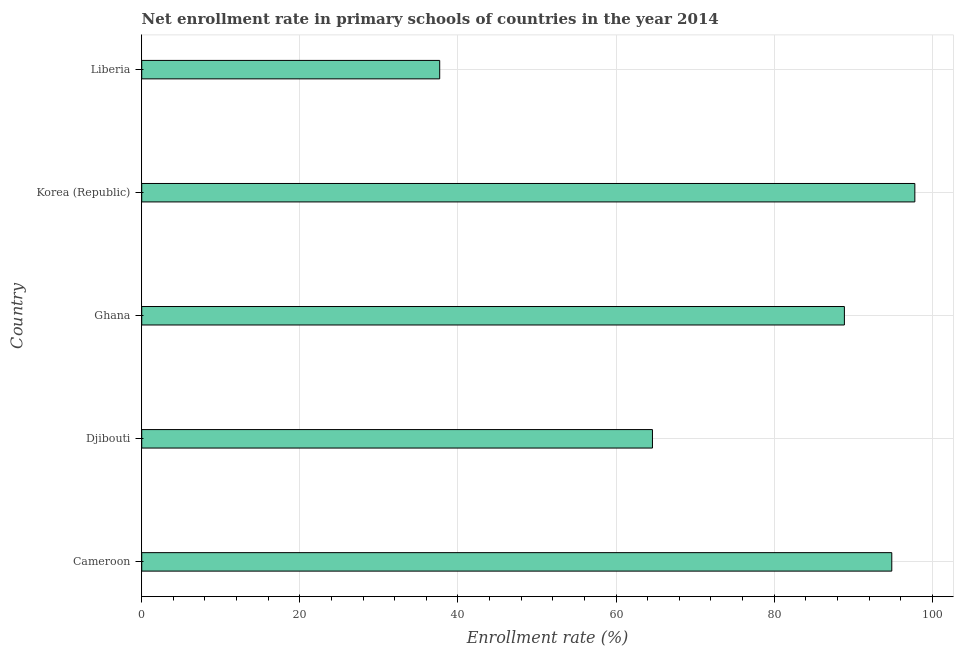What is the title of the graph?
Your answer should be compact. Net enrollment rate in primary schools of countries in the year 2014. What is the label or title of the X-axis?
Provide a succinct answer. Enrollment rate (%). What is the net enrollment rate in primary schools in Cameroon?
Your answer should be very brief. 94.87. Across all countries, what is the maximum net enrollment rate in primary schools?
Ensure brevity in your answer.  97.79. Across all countries, what is the minimum net enrollment rate in primary schools?
Offer a terse response. 37.69. In which country was the net enrollment rate in primary schools maximum?
Offer a very short reply. Korea (Republic). In which country was the net enrollment rate in primary schools minimum?
Give a very brief answer. Liberia. What is the sum of the net enrollment rate in primary schools?
Your answer should be very brief. 383.82. What is the difference between the net enrollment rate in primary schools in Ghana and Korea (Republic)?
Your answer should be compact. -8.91. What is the average net enrollment rate in primary schools per country?
Offer a very short reply. 76.76. What is the median net enrollment rate in primary schools?
Give a very brief answer. 88.88. In how many countries, is the net enrollment rate in primary schools greater than 72 %?
Keep it short and to the point. 3. Is the difference between the net enrollment rate in primary schools in Djibouti and Ghana greater than the difference between any two countries?
Keep it short and to the point. No. What is the difference between the highest and the second highest net enrollment rate in primary schools?
Keep it short and to the point. 2.92. What is the difference between the highest and the lowest net enrollment rate in primary schools?
Provide a succinct answer. 60.1. Are all the bars in the graph horizontal?
Offer a very short reply. Yes. How many countries are there in the graph?
Give a very brief answer. 5. Are the values on the major ticks of X-axis written in scientific E-notation?
Your answer should be compact. No. What is the Enrollment rate (%) of Cameroon?
Provide a succinct answer. 94.87. What is the Enrollment rate (%) of Djibouti?
Provide a short and direct response. 64.6. What is the Enrollment rate (%) of Ghana?
Offer a very short reply. 88.88. What is the Enrollment rate (%) of Korea (Republic)?
Offer a very short reply. 97.79. What is the Enrollment rate (%) of Liberia?
Your answer should be very brief. 37.69. What is the difference between the Enrollment rate (%) in Cameroon and Djibouti?
Your answer should be very brief. 30.27. What is the difference between the Enrollment rate (%) in Cameroon and Ghana?
Offer a terse response. 5.99. What is the difference between the Enrollment rate (%) in Cameroon and Korea (Republic)?
Provide a short and direct response. -2.92. What is the difference between the Enrollment rate (%) in Cameroon and Liberia?
Offer a very short reply. 57.18. What is the difference between the Enrollment rate (%) in Djibouti and Ghana?
Offer a very short reply. -24.28. What is the difference between the Enrollment rate (%) in Djibouti and Korea (Republic)?
Your response must be concise. -33.19. What is the difference between the Enrollment rate (%) in Djibouti and Liberia?
Provide a short and direct response. 26.91. What is the difference between the Enrollment rate (%) in Ghana and Korea (Republic)?
Your response must be concise. -8.91. What is the difference between the Enrollment rate (%) in Ghana and Liberia?
Offer a terse response. 51.19. What is the difference between the Enrollment rate (%) in Korea (Republic) and Liberia?
Ensure brevity in your answer.  60.1. What is the ratio of the Enrollment rate (%) in Cameroon to that in Djibouti?
Offer a terse response. 1.47. What is the ratio of the Enrollment rate (%) in Cameroon to that in Ghana?
Provide a succinct answer. 1.07. What is the ratio of the Enrollment rate (%) in Cameroon to that in Korea (Republic)?
Provide a short and direct response. 0.97. What is the ratio of the Enrollment rate (%) in Cameroon to that in Liberia?
Provide a short and direct response. 2.52. What is the ratio of the Enrollment rate (%) in Djibouti to that in Ghana?
Make the answer very short. 0.73. What is the ratio of the Enrollment rate (%) in Djibouti to that in Korea (Republic)?
Provide a succinct answer. 0.66. What is the ratio of the Enrollment rate (%) in Djibouti to that in Liberia?
Provide a short and direct response. 1.71. What is the ratio of the Enrollment rate (%) in Ghana to that in Korea (Republic)?
Keep it short and to the point. 0.91. What is the ratio of the Enrollment rate (%) in Ghana to that in Liberia?
Offer a very short reply. 2.36. What is the ratio of the Enrollment rate (%) in Korea (Republic) to that in Liberia?
Provide a short and direct response. 2.59. 